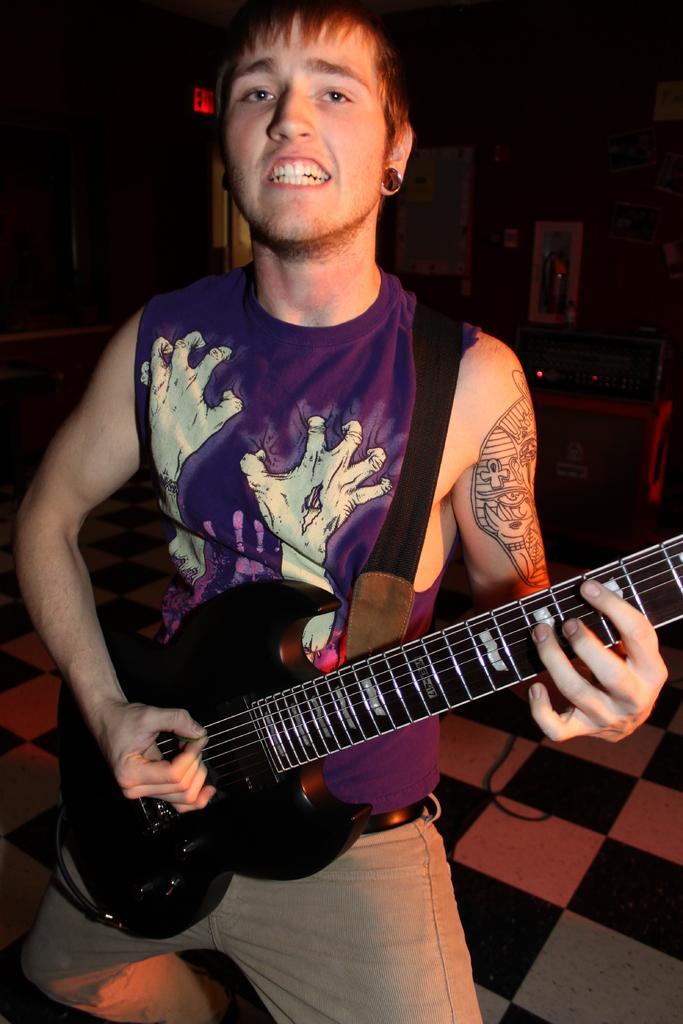How would you summarize this image in a sentence or two? This is the picture of a man in purple t shirt was holding a guitar and singing a song and the man is standing on the floor. Behind the man there is a table on the table there are some music systems and a wall. 